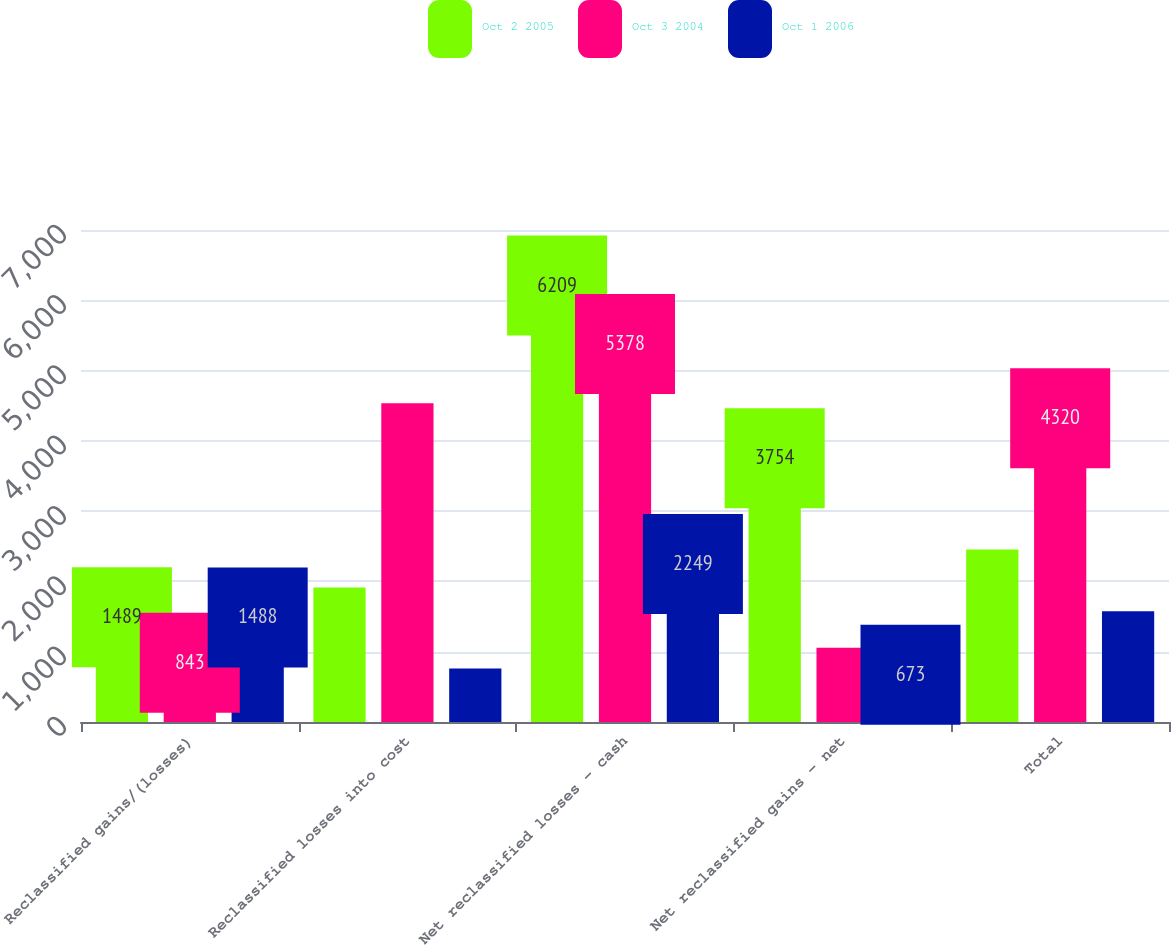Convert chart. <chart><loc_0><loc_0><loc_500><loc_500><stacked_bar_chart><ecel><fcel>Reclassified gains/(losses)<fcel>Reclassified losses into cost<fcel>Net reclassified losses - cash<fcel>Net reclassified gains - net<fcel>Total<nl><fcel>Oct 2 2005<fcel>1489<fcel>1912.5<fcel>6209<fcel>3754<fcel>2455<nl><fcel>Oct 3 2004<fcel>843<fcel>4535<fcel>5378<fcel>1058<fcel>4320<nl><fcel>Oct 1 2006<fcel>1488<fcel>761<fcel>2249<fcel>673<fcel>1576<nl></chart> 